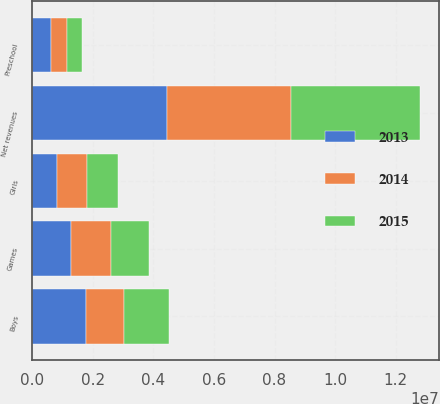<chart> <loc_0><loc_0><loc_500><loc_500><stacked_bar_chart><ecel><fcel>Boys<fcel>Games<fcel>Girls<fcel>Preschool<fcel>Net revenues<nl><fcel>2013<fcel>1.77592e+06<fcel>1.27653e+06<fcel>798240<fcel>596820<fcel>4.44751e+06<nl><fcel>2015<fcel>1.48395e+06<fcel>1.25978e+06<fcel>1.02263e+06<fcel>510840<fcel>4.27721e+06<nl><fcel>2014<fcel>1.23761e+06<fcel>1.3112e+06<fcel>1.0017e+06<fcel>531637<fcel>4.08216e+06<nl></chart> 